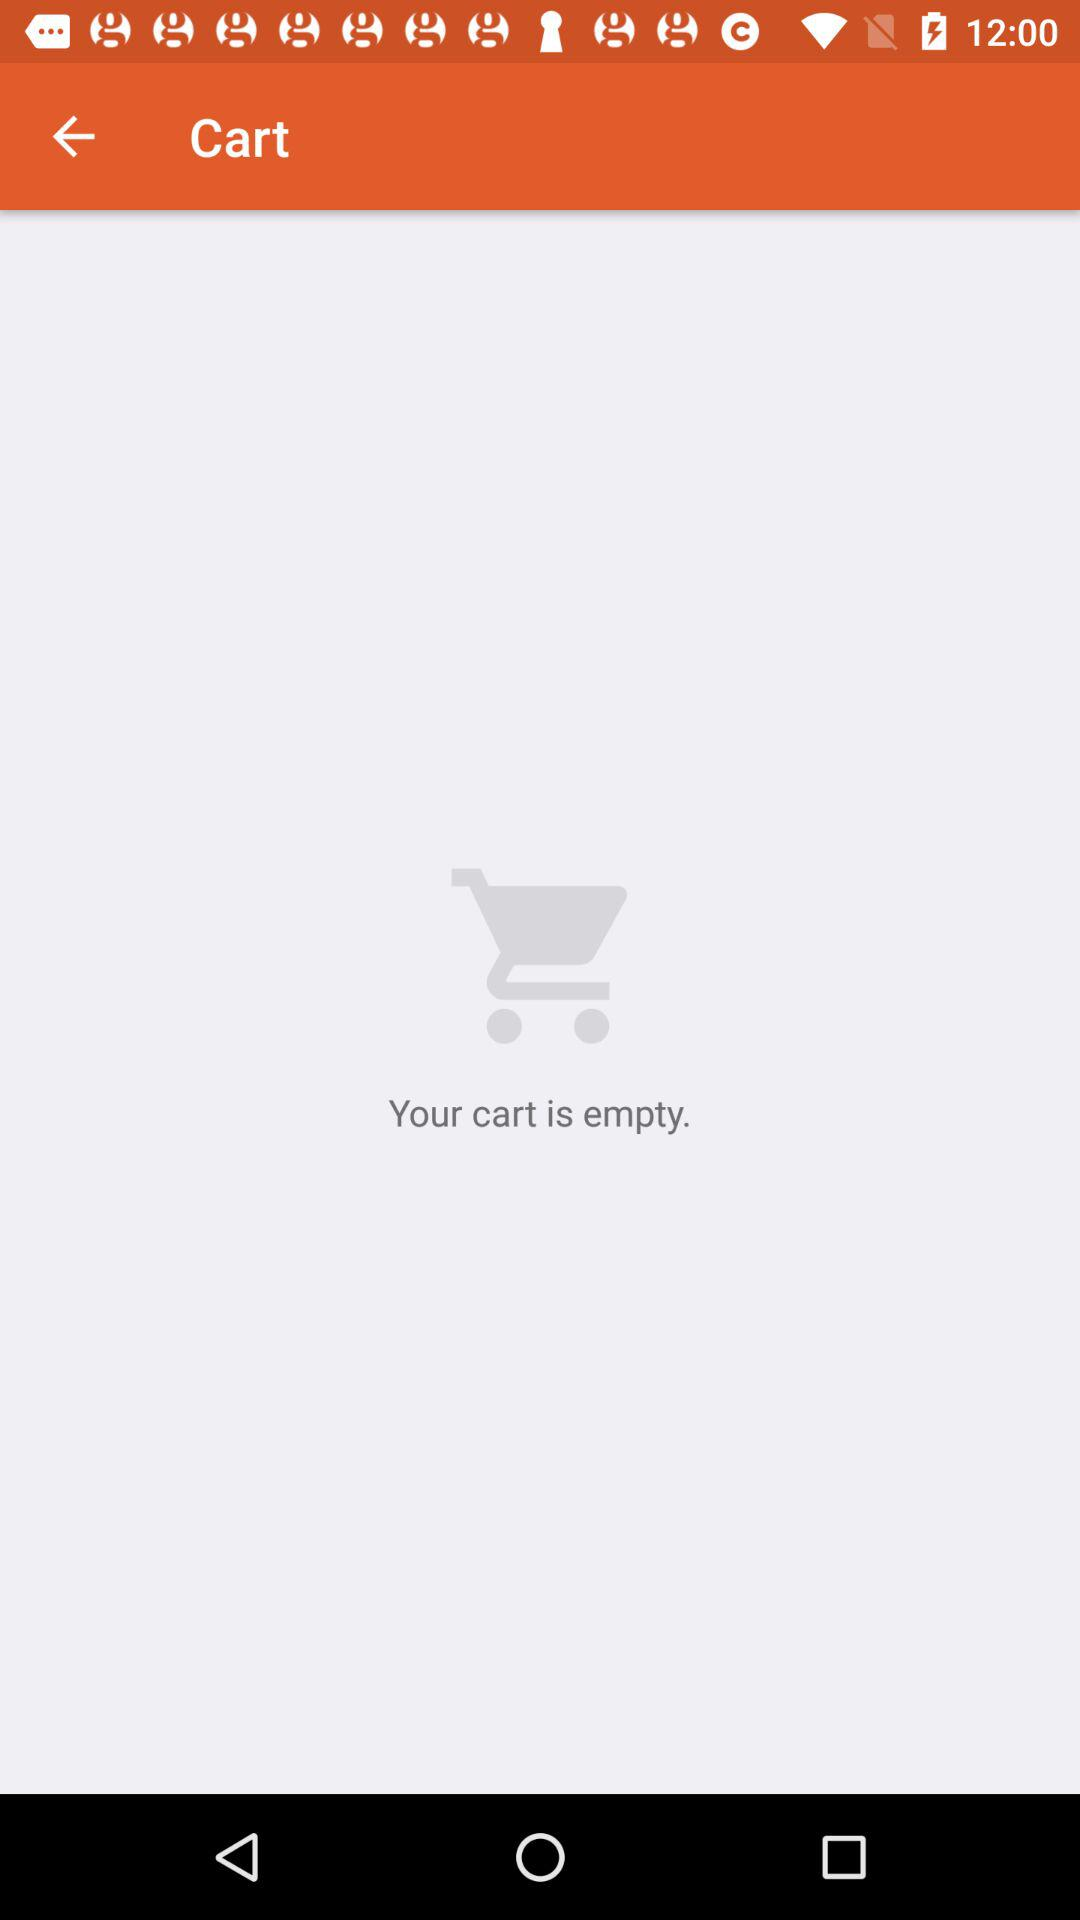How many orders are in the cart? There are no orders in the cart. 